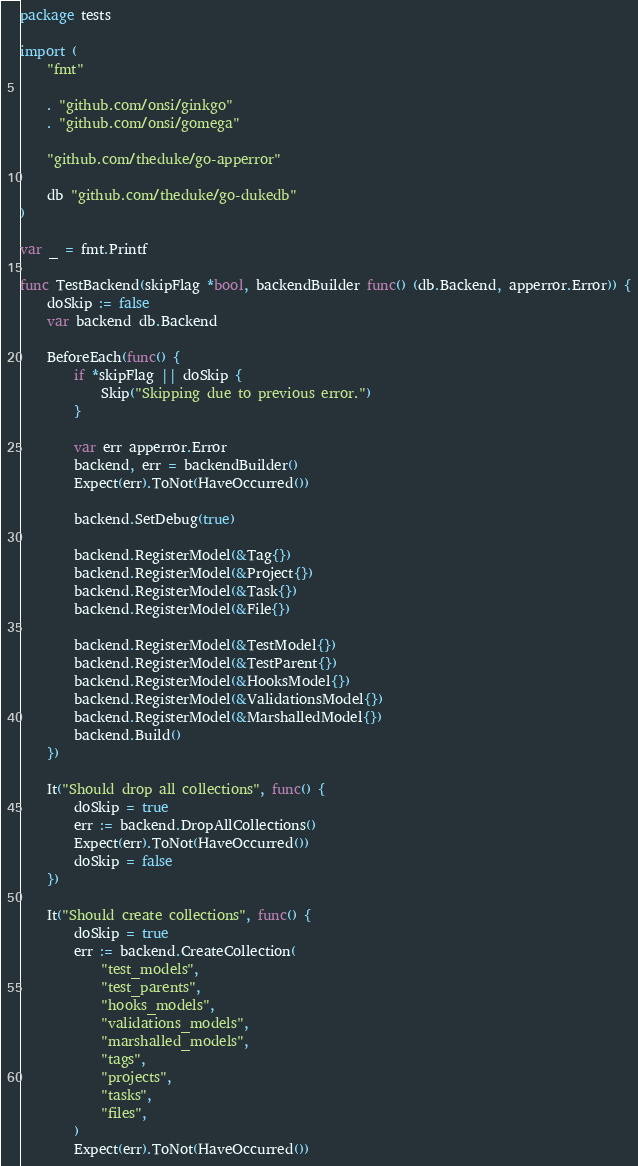Convert code to text. <code><loc_0><loc_0><loc_500><loc_500><_Go_>package tests

import (
	"fmt"

	. "github.com/onsi/ginkgo"
	. "github.com/onsi/gomega"

	"github.com/theduke/go-apperror"

	db "github.com/theduke/go-dukedb"
)

var _ = fmt.Printf

func TestBackend(skipFlag *bool, backendBuilder func() (db.Backend, apperror.Error)) {
	doSkip := false
	var backend db.Backend

	BeforeEach(func() {
		if *skipFlag || doSkip {
			Skip("Skipping due to previous error.")
		}

		var err apperror.Error
		backend, err = backendBuilder()
		Expect(err).ToNot(HaveOccurred())

		backend.SetDebug(true)

		backend.RegisterModel(&Tag{})
		backend.RegisterModel(&Project{})
		backend.RegisterModel(&Task{})
		backend.RegisterModel(&File{})

		backend.RegisterModel(&TestModel{})
		backend.RegisterModel(&TestParent{})
		backend.RegisterModel(&HooksModel{})
		backend.RegisterModel(&ValidationsModel{})
		backend.RegisterModel(&MarshalledModel{})
		backend.Build()
	})

	It("Should drop all collections", func() {
		doSkip = true
		err := backend.DropAllCollections()
		Expect(err).ToNot(HaveOccurred())
		doSkip = false
	})

	It("Should create collections", func() {
		doSkip = true
		err := backend.CreateCollection(
			"test_models",
			"test_parents",
			"hooks_models",
			"validations_models",
			"marshalled_models",
			"tags",
			"projects",
			"tasks",
			"files",
		)
		Expect(err).ToNot(HaveOccurred())</code> 